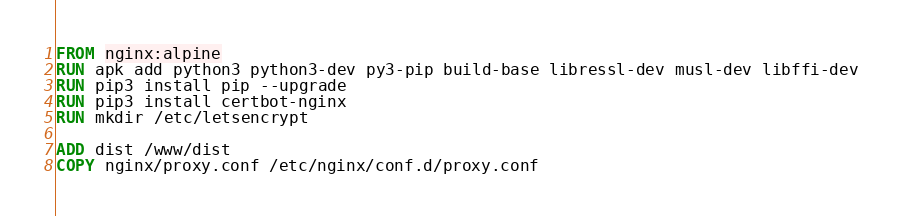Convert code to text. <code><loc_0><loc_0><loc_500><loc_500><_Dockerfile_>FROM nginx:alpine
RUN apk add python3 python3-dev py3-pip build-base libressl-dev musl-dev libffi-dev
RUN pip3 install pip --upgrade
RUN pip3 install certbot-nginx
RUN mkdir /etc/letsencrypt

ADD dist /www/dist
COPY nginx/proxy.conf /etc/nginx/conf.d/proxy.conf
</code> 